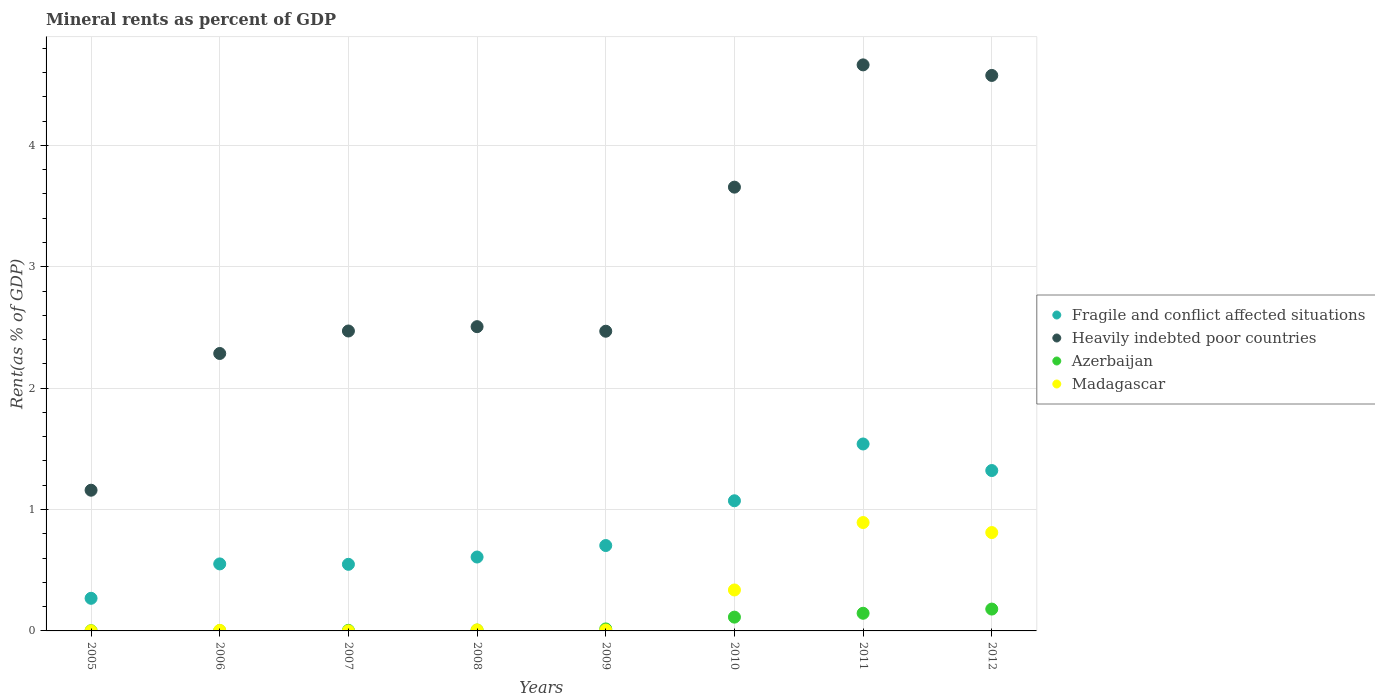Is the number of dotlines equal to the number of legend labels?
Provide a succinct answer. Yes. What is the mineral rent in Heavily indebted poor countries in 2011?
Ensure brevity in your answer.  4.66. Across all years, what is the maximum mineral rent in Azerbaijan?
Give a very brief answer. 0.18. Across all years, what is the minimum mineral rent in Madagascar?
Ensure brevity in your answer.  0. In which year was the mineral rent in Heavily indebted poor countries maximum?
Your response must be concise. 2011. In which year was the mineral rent in Heavily indebted poor countries minimum?
Give a very brief answer. 2005. What is the total mineral rent in Fragile and conflict affected situations in the graph?
Provide a short and direct response. 6.62. What is the difference between the mineral rent in Heavily indebted poor countries in 2009 and that in 2011?
Provide a short and direct response. -2.19. What is the difference between the mineral rent in Azerbaijan in 2006 and the mineral rent in Heavily indebted poor countries in 2010?
Your answer should be compact. -3.65. What is the average mineral rent in Madagascar per year?
Make the answer very short. 0.26. In the year 2010, what is the difference between the mineral rent in Madagascar and mineral rent in Fragile and conflict affected situations?
Provide a short and direct response. -0.73. In how many years, is the mineral rent in Heavily indebted poor countries greater than 0.8 %?
Make the answer very short. 8. What is the ratio of the mineral rent in Azerbaijan in 2006 to that in 2009?
Your answer should be very brief. 0.13. Is the mineral rent in Heavily indebted poor countries in 2008 less than that in 2011?
Keep it short and to the point. Yes. Is the difference between the mineral rent in Madagascar in 2006 and 2012 greater than the difference between the mineral rent in Fragile and conflict affected situations in 2006 and 2012?
Offer a very short reply. No. What is the difference between the highest and the second highest mineral rent in Heavily indebted poor countries?
Give a very brief answer. 0.09. What is the difference between the highest and the lowest mineral rent in Azerbaijan?
Give a very brief answer. 0.18. In how many years, is the mineral rent in Fragile and conflict affected situations greater than the average mineral rent in Fragile and conflict affected situations taken over all years?
Your answer should be very brief. 3. Is it the case that in every year, the sum of the mineral rent in Madagascar and mineral rent in Heavily indebted poor countries  is greater than the sum of mineral rent in Fragile and conflict affected situations and mineral rent in Azerbaijan?
Offer a terse response. No. Does the mineral rent in Heavily indebted poor countries monotonically increase over the years?
Keep it short and to the point. No. How many dotlines are there?
Ensure brevity in your answer.  4. Are the values on the major ticks of Y-axis written in scientific E-notation?
Keep it short and to the point. No. Does the graph contain any zero values?
Offer a very short reply. No. Does the graph contain grids?
Your response must be concise. Yes. What is the title of the graph?
Offer a very short reply. Mineral rents as percent of GDP. What is the label or title of the Y-axis?
Your answer should be compact. Rent(as % of GDP). What is the Rent(as % of GDP) in Fragile and conflict affected situations in 2005?
Keep it short and to the point. 0.27. What is the Rent(as % of GDP) in Heavily indebted poor countries in 2005?
Your response must be concise. 1.16. What is the Rent(as % of GDP) of Azerbaijan in 2005?
Ensure brevity in your answer.  0. What is the Rent(as % of GDP) in Madagascar in 2005?
Ensure brevity in your answer.  0. What is the Rent(as % of GDP) of Fragile and conflict affected situations in 2006?
Offer a terse response. 0.55. What is the Rent(as % of GDP) in Heavily indebted poor countries in 2006?
Ensure brevity in your answer.  2.29. What is the Rent(as % of GDP) of Azerbaijan in 2006?
Ensure brevity in your answer.  0. What is the Rent(as % of GDP) in Madagascar in 2006?
Ensure brevity in your answer.  0. What is the Rent(as % of GDP) of Fragile and conflict affected situations in 2007?
Provide a succinct answer. 0.55. What is the Rent(as % of GDP) of Heavily indebted poor countries in 2007?
Keep it short and to the point. 2.47. What is the Rent(as % of GDP) in Azerbaijan in 2007?
Provide a succinct answer. 0. What is the Rent(as % of GDP) in Madagascar in 2007?
Provide a short and direct response. 0. What is the Rent(as % of GDP) in Fragile and conflict affected situations in 2008?
Make the answer very short. 0.61. What is the Rent(as % of GDP) in Heavily indebted poor countries in 2008?
Provide a succinct answer. 2.51. What is the Rent(as % of GDP) of Azerbaijan in 2008?
Provide a succinct answer. 0.01. What is the Rent(as % of GDP) of Madagascar in 2008?
Provide a short and direct response. 0.01. What is the Rent(as % of GDP) of Fragile and conflict affected situations in 2009?
Provide a short and direct response. 0.7. What is the Rent(as % of GDP) in Heavily indebted poor countries in 2009?
Your answer should be compact. 2.47. What is the Rent(as % of GDP) of Azerbaijan in 2009?
Give a very brief answer. 0.02. What is the Rent(as % of GDP) in Madagascar in 2009?
Your answer should be very brief. 0.01. What is the Rent(as % of GDP) in Fragile and conflict affected situations in 2010?
Keep it short and to the point. 1.07. What is the Rent(as % of GDP) in Heavily indebted poor countries in 2010?
Your response must be concise. 3.66. What is the Rent(as % of GDP) in Azerbaijan in 2010?
Your response must be concise. 0.11. What is the Rent(as % of GDP) of Madagascar in 2010?
Make the answer very short. 0.34. What is the Rent(as % of GDP) of Fragile and conflict affected situations in 2011?
Offer a very short reply. 1.54. What is the Rent(as % of GDP) of Heavily indebted poor countries in 2011?
Give a very brief answer. 4.66. What is the Rent(as % of GDP) of Azerbaijan in 2011?
Your response must be concise. 0.15. What is the Rent(as % of GDP) in Madagascar in 2011?
Give a very brief answer. 0.89. What is the Rent(as % of GDP) in Fragile and conflict affected situations in 2012?
Your answer should be very brief. 1.32. What is the Rent(as % of GDP) in Heavily indebted poor countries in 2012?
Make the answer very short. 4.58. What is the Rent(as % of GDP) in Azerbaijan in 2012?
Offer a terse response. 0.18. What is the Rent(as % of GDP) of Madagascar in 2012?
Give a very brief answer. 0.81. Across all years, what is the maximum Rent(as % of GDP) of Fragile and conflict affected situations?
Offer a terse response. 1.54. Across all years, what is the maximum Rent(as % of GDP) of Heavily indebted poor countries?
Keep it short and to the point. 4.66. Across all years, what is the maximum Rent(as % of GDP) in Azerbaijan?
Make the answer very short. 0.18. Across all years, what is the maximum Rent(as % of GDP) of Madagascar?
Offer a terse response. 0.89. Across all years, what is the minimum Rent(as % of GDP) in Fragile and conflict affected situations?
Provide a short and direct response. 0.27. Across all years, what is the minimum Rent(as % of GDP) in Heavily indebted poor countries?
Offer a terse response. 1.16. Across all years, what is the minimum Rent(as % of GDP) in Azerbaijan?
Make the answer very short. 0. Across all years, what is the minimum Rent(as % of GDP) of Madagascar?
Give a very brief answer. 0. What is the total Rent(as % of GDP) in Fragile and conflict affected situations in the graph?
Keep it short and to the point. 6.62. What is the total Rent(as % of GDP) in Heavily indebted poor countries in the graph?
Your answer should be very brief. 23.79. What is the total Rent(as % of GDP) of Azerbaijan in the graph?
Ensure brevity in your answer.  0.47. What is the total Rent(as % of GDP) of Madagascar in the graph?
Your response must be concise. 2.06. What is the difference between the Rent(as % of GDP) of Fragile and conflict affected situations in 2005 and that in 2006?
Provide a succinct answer. -0.28. What is the difference between the Rent(as % of GDP) in Heavily indebted poor countries in 2005 and that in 2006?
Your response must be concise. -1.13. What is the difference between the Rent(as % of GDP) in Azerbaijan in 2005 and that in 2006?
Provide a short and direct response. -0. What is the difference between the Rent(as % of GDP) of Madagascar in 2005 and that in 2006?
Provide a short and direct response. -0. What is the difference between the Rent(as % of GDP) of Fragile and conflict affected situations in 2005 and that in 2007?
Provide a succinct answer. -0.28. What is the difference between the Rent(as % of GDP) in Heavily indebted poor countries in 2005 and that in 2007?
Offer a terse response. -1.31. What is the difference between the Rent(as % of GDP) in Azerbaijan in 2005 and that in 2007?
Your answer should be compact. -0. What is the difference between the Rent(as % of GDP) in Madagascar in 2005 and that in 2007?
Ensure brevity in your answer.  0. What is the difference between the Rent(as % of GDP) of Fragile and conflict affected situations in 2005 and that in 2008?
Offer a terse response. -0.34. What is the difference between the Rent(as % of GDP) of Heavily indebted poor countries in 2005 and that in 2008?
Provide a succinct answer. -1.35. What is the difference between the Rent(as % of GDP) in Azerbaijan in 2005 and that in 2008?
Your answer should be very brief. -0.01. What is the difference between the Rent(as % of GDP) of Madagascar in 2005 and that in 2008?
Give a very brief answer. -0.01. What is the difference between the Rent(as % of GDP) in Fragile and conflict affected situations in 2005 and that in 2009?
Provide a short and direct response. -0.43. What is the difference between the Rent(as % of GDP) of Heavily indebted poor countries in 2005 and that in 2009?
Keep it short and to the point. -1.31. What is the difference between the Rent(as % of GDP) in Azerbaijan in 2005 and that in 2009?
Provide a short and direct response. -0.01. What is the difference between the Rent(as % of GDP) of Madagascar in 2005 and that in 2009?
Offer a very short reply. -0.01. What is the difference between the Rent(as % of GDP) of Fragile and conflict affected situations in 2005 and that in 2010?
Give a very brief answer. -0.8. What is the difference between the Rent(as % of GDP) of Heavily indebted poor countries in 2005 and that in 2010?
Your answer should be very brief. -2.5. What is the difference between the Rent(as % of GDP) of Azerbaijan in 2005 and that in 2010?
Make the answer very short. -0.11. What is the difference between the Rent(as % of GDP) in Madagascar in 2005 and that in 2010?
Offer a terse response. -0.34. What is the difference between the Rent(as % of GDP) in Fragile and conflict affected situations in 2005 and that in 2011?
Make the answer very short. -1.27. What is the difference between the Rent(as % of GDP) of Heavily indebted poor countries in 2005 and that in 2011?
Offer a very short reply. -3.5. What is the difference between the Rent(as % of GDP) in Azerbaijan in 2005 and that in 2011?
Make the answer very short. -0.14. What is the difference between the Rent(as % of GDP) of Madagascar in 2005 and that in 2011?
Offer a very short reply. -0.89. What is the difference between the Rent(as % of GDP) of Fragile and conflict affected situations in 2005 and that in 2012?
Provide a short and direct response. -1.05. What is the difference between the Rent(as % of GDP) of Heavily indebted poor countries in 2005 and that in 2012?
Provide a short and direct response. -3.42. What is the difference between the Rent(as % of GDP) of Azerbaijan in 2005 and that in 2012?
Keep it short and to the point. -0.18. What is the difference between the Rent(as % of GDP) of Madagascar in 2005 and that in 2012?
Your answer should be compact. -0.81. What is the difference between the Rent(as % of GDP) in Fragile and conflict affected situations in 2006 and that in 2007?
Offer a terse response. 0. What is the difference between the Rent(as % of GDP) in Heavily indebted poor countries in 2006 and that in 2007?
Offer a very short reply. -0.19. What is the difference between the Rent(as % of GDP) of Azerbaijan in 2006 and that in 2007?
Make the answer very short. -0. What is the difference between the Rent(as % of GDP) in Madagascar in 2006 and that in 2007?
Ensure brevity in your answer.  0. What is the difference between the Rent(as % of GDP) in Fragile and conflict affected situations in 2006 and that in 2008?
Ensure brevity in your answer.  -0.06. What is the difference between the Rent(as % of GDP) in Heavily indebted poor countries in 2006 and that in 2008?
Give a very brief answer. -0.22. What is the difference between the Rent(as % of GDP) in Azerbaijan in 2006 and that in 2008?
Offer a terse response. -0. What is the difference between the Rent(as % of GDP) of Madagascar in 2006 and that in 2008?
Ensure brevity in your answer.  -0. What is the difference between the Rent(as % of GDP) in Fragile and conflict affected situations in 2006 and that in 2009?
Make the answer very short. -0.15. What is the difference between the Rent(as % of GDP) in Heavily indebted poor countries in 2006 and that in 2009?
Your answer should be very brief. -0.18. What is the difference between the Rent(as % of GDP) in Azerbaijan in 2006 and that in 2009?
Keep it short and to the point. -0.01. What is the difference between the Rent(as % of GDP) in Madagascar in 2006 and that in 2009?
Make the answer very short. -0. What is the difference between the Rent(as % of GDP) of Fragile and conflict affected situations in 2006 and that in 2010?
Your answer should be compact. -0.52. What is the difference between the Rent(as % of GDP) in Heavily indebted poor countries in 2006 and that in 2010?
Your answer should be very brief. -1.37. What is the difference between the Rent(as % of GDP) in Azerbaijan in 2006 and that in 2010?
Your answer should be very brief. -0.11. What is the difference between the Rent(as % of GDP) in Madagascar in 2006 and that in 2010?
Make the answer very short. -0.33. What is the difference between the Rent(as % of GDP) of Fragile and conflict affected situations in 2006 and that in 2011?
Your answer should be compact. -0.99. What is the difference between the Rent(as % of GDP) of Heavily indebted poor countries in 2006 and that in 2011?
Offer a terse response. -2.38. What is the difference between the Rent(as % of GDP) in Azerbaijan in 2006 and that in 2011?
Provide a short and direct response. -0.14. What is the difference between the Rent(as % of GDP) in Madagascar in 2006 and that in 2011?
Offer a very short reply. -0.89. What is the difference between the Rent(as % of GDP) of Fragile and conflict affected situations in 2006 and that in 2012?
Offer a very short reply. -0.77. What is the difference between the Rent(as % of GDP) in Heavily indebted poor countries in 2006 and that in 2012?
Your answer should be very brief. -2.29. What is the difference between the Rent(as % of GDP) of Azerbaijan in 2006 and that in 2012?
Give a very brief answer. -0.18. What is the difference between the Rent(as % of GDP) of Madagascar in 2006 and that in 2012?
Give a very brief answer. -0.81. What is the difference between the Rent(as % of GDP) of Fragile and conflict affected situations in 2007 and that in 2008?
Give a very brief answer. -0.06. What is the difference between the Rent(as % of GDP) of Heavily indebted poor countries in 2007 and that in 2008?
Offer a very short reply. -0.04. What is the difference between the Rent(as % of GDP) of Azerbaijan in 2007 and that in 2008?
Make the answer very short. -0. What is the difference between the Rent(as % of GDP) in Madagascar in 2007 and that in 2008?
Keep it short and to the point. -0.01. What is the difference between the Rent(as % of GDP) in Fragile and conflict affected situations in 2007 and that in 2009?
Ensure brevity in your answer.  -0.15. What is the difference between the Rent(as % of GDP) of Heavily indebted poor countries in 2007 and that in 2009?
Offer a terse response. 0. What is the difference between the Rent(as % of GDP) of Azerbaijan in 2007 and that in 2009?
Your answer should be very brief. -0.01. What is the difference between the Rent(as % of GDP) of Madagascar in 2007 and that in 2009?
Keep it short and to the point. -0.01. What is the difference between the Rent(as % of GDP) of Fragile and conflict affected situations in 2007 and that in 2010?
Keep it short and to the point. -0.52. What is the difference between the Rent(as % of GDP) in Heavily indebted poor countries in 2007 and that in 2010?
Provide a short and direct response. -1.19. What is the difference between the Rent(as % of GDP) of Azerbaijan in 2007 and that in 2010?
Your answer should be very brief. -0.11. What is the difference between the Rent(as % of GDP) of Madagascar in 2007 and that in 2010?
Keep it short and to the point. -0.34. What is the difference between the Rent(as % of GDP) of Fragile and conflict affected situations in 2007 and that in 2011?
Give a very brief answer. -0.99. What is the difference between the Rent(as % of GDP) in Heavily indebted poor countries in 2007 and that in 2011?
Give a very brief answer. -2.19. What is the difference between the Rent(as % of GDP) of Azerbaijan in 2007 and that in 2011?
Ensure brevity in your answer.  -0.14. What is the difference between the Rent(as % of GDP) of Madagascar in 2007 and that in 2011?
Keep it short and to the point. -0.89. What is the difference between the Rent(as % of GDP) in Fragile and conflict affected situations in 2007 and that in 2012?
Make the answer very short. -0.77. What is the difference between the Rent(as % of GDP) of Heavily indebted poor countries in 2007 and that in 2012?
Your response must be concise. -2.11. What is the difference between the Rent(as % of GDP) of Azerbaijan in 2007 and that in 2012?
Ensure brevity in your answer.  -0.18. What is the difference between the Rent(as % of GDP) in Madagascar in 2007 and that in 2012?
Keep it short and to the point. -0.81. What is the difference between the Rent(as % of GDP) in Fragile and conflict affected situations in 2008 and that in 2009?
Provide a short and direct response. -0.09. What is the difference between the Rent(as % of GDP) of Heavily indebted poor countries in 2008 and that in 2009?
Provide a succinct answer. 0.04. What is the difference between the Rent(as % of GDP) in Azerbaijan in 2008 and that in 2009?
Your answer should be compact. -0.01. What is the difference between the Rent(as % of GDP) in Madagascar in 2008 and that in 2009?
Make the answer very short. 0. What is the difference between the Rent(as % of GDP) of Fragile and conflict affected situations in 2008 and that in 2010?
Your answer should be very brief. -0.46. What is the difference between the Rent(as % of GDP) in Heavily indebted poor countries in 2008 and that in 2010?
Provide a succinct answer. -1.15. What is the difference between the Rent(as % of GDP) of Azerbaijan in 2008 and that in 2010?
Ensure brevity in your answer.  -0.11. What is the difference between the Rent(as % of GDP) of Madagascar in 2008 and that in 2010?
Offer a very short reply. -0.33. What is the difference between the Rent(as % of GDP) in Fragile and conflict affected situations in 2008 and that in 2011?
Provide a short and direct response. -0.93. What is the difference between the Rent(as % of GDP) of Heavily indebted poor countries in 2008 and that in 2011?
Give a very brief answer. -2.16. What is the difference between the Rent(as % of GDP) of Azerbaijan in 2008 and that in 2011?
Ensure brevity in your answer.  -0.14. What is the difference between the Rent(as % of GDP) in Madagascar in 2008 and that in 2011?
Offer a terse response. -0.88. What is the difference between the Rent(as % of GDP) of Fragile and conflict affected situations in 2008 and that in 2012?
Keep it short and to the point. -0.71. What is the difference between the Rent(as % of GDP) in Heavily indebted poor countries in 2008 and that in 2012?
Provide a succinct answer. -2.07. What is the difference between the Rent(as % of GDP) in Azerbaijan in 2008 and that in 2012?
Provide a short and direct response. -0.17. What is the difference between the Rent(as % of GDP) in Madagascar in 2008 and that in 2012?
Give a very brief answer. -0.8. What is the difference between the Rent(as % of GDP) of Fragile and conflict affected situations in 2009 and that in 2010?
Make the answer very short. -0.37. What is the difference between the Rent(as % of GDP) of Heavily indebted poor countries in 2009 and that in 2010?
Give a very brief answer. -1.19. What is the difference between the Rent(as % of GDP) of Azerbaijan in 2009 and that in 2010?
Offer a very short reply. -0.1. What is the difference between the Rent(as % of GDP) of Madagascar in 2009 and that in 2010?
Make the answer very short. -0.33. What is the difference between the Rent(as % of GDP) in Fragile and conflict affected situations in 2009 and that in 2011?
Ensure brevity in your answer.  -0.84. What is the difference between the Rent(as % of GDP) in Heavily indebted poor countries in 2009 and that in 2011?
Offer a very short reply. -2.19. What is the difference between the Rent(as % of GDP) in Azerbaijan in 2009 and that in 2011?
Your answer should be compact. -0.13. What is the difference between the Rent(as % of GDP) in Madagascar in 2009 and that in 2011?
Your answer should be very brief. -0.89. What is the difference between the Rent(as % of GDP) in Fragile and conflict affected situations in 2009 and that in 2012?
Your answer should be very brief. -0.62. What is the difference between the Rent(as % of GDP) in Heavily indebted poor countries in 2009 and that in 2012?
Provide a short and direct response. -2.11. What is the difference between the Rent(as % of GDP) in Azerbaijan in 2009 and that in 2012?
Your answer should be very brief. -0.16. What is the difference between the Rent(as % of GDP) of Madagascar in 2009 and that in 2012?
Give a very brief answer. -0.8. What is the difference between the Rent(as % of GDP) of Fragile and conflict affected situations in 2010 and that in 2011?
Make the answer very short. -0.47. What is the difference between the Rent(as % of GDP) of Heavily indebted poor countries in 2010 and that in 2011?
Ensure brevity in your answer.  -1.01. What is the difference between the Rent(as % of GDP) of Azerbaijan in 2010 and that in 2011?
Offer a very short reply. -0.03. What is the difference between the Rent(as % of GDP) of Madagascar in 2010 and that in 2011?
Your answer should be compact. -0.56. What is the difference between the Rent(as % of GDP) in Fragile and conflict affected situations in 2010 and that in 2012?
Keep it short and to the point. -0.25. What is the difference between the Rent(as % of GDP) of Heavily indebted poor countries in 2010 and that in 2012?
Your response must be concise. -0.92. What is the difference between the Rent(as % of GDP) of Azerbaijan in 2010 and that in 2012?
Give a very brief answer. -0.07. What is the difference between the Rent(as % of GDP) in Madagascar in 2010 and that in 2012?
Give a very brief answer. -0.47. What is the difference between the Rent(as % of GDP) of Fragile and conflict affected situations in 2011 and that in 2012?
Your answer should be very brief. 0.22. What is the difference between the Rent(as % of GDP) of Heavily indebted poor countries in 2011 and that in 2012?
Make the answer very short. 0.09. What is the difference between the Rent(as % of GDP) of Azerbaijan in 2011 and that in 2012?
Keep it short and to the point. -0.03. What is the difference between the Rent(as % of GDP) in Madagascar in 2011 and that in 2012?
Offer a terse response. 0.08. What is the difference between the Rent(as % of GDP) in Fragile and conflict affected situations in 2005 and the Rent(as % of GDP) in Heavily indebted poor countries in 2006?
Make the answer very short. -2.02. What is the difference between the Rent(as % of GDP) in Fragile and conflict affected situations in 2005 and the Rent(as % of GDP) in Azerbaijan in 2006?
Keep it short and to the point. 0.27. What is the difference between the Rent(as % of GDP) in Fragile and conflict affected situations in 2005 and the Rent(as % of GDP) in Madagascar in 2006?
Ensure brevity in your answer.  0.26. What is the difference between the Rent(as % of GDP) in Heavily indebted poor countries in 2005 and the Rent(as % of GDP) in Azerbaijan in 2006?
Offer a terse response. 1.16. What is the difference between the Rent(as % of GDP) of Heavily indebted poor countries in 2005 and the Rent(as % of GDP) of Madagascar in 2006?
Give a very brief answer. 1.15. What is the difference between the Rent(as % of GDP) of Azerbaijan in 2005 and the Rent(as % of GDP) of Madagascar in 2006?
Offer a terse response. -0. What is the difference between the Rent(as % of GDP) of Fragile and conflict affected situations in 2005 and the Rent(as % of GDP) of Heavily indebted poor countries in 2007?
Your answer should be compact. -2.2. What is the difference between the Rent(as % of GDP) in Fragile and conflict affected situations in 2005 and the Rent(as % of GDP) in Azerbaijan in 2007?
Offer a very short reply. 0.26. What is the difference between the Rent(as % of GDP) of Fragile and conflict affected situations in 2005 and the Rent(as % of GDP) of Madagascar in 2007?
Your response must be concise. 0.27. What is the difference between the Rent(as % of GDP) of Heavily indebted poor countries in 2005 and the Rent(as % of GDP) of Azerbaijan in 2007?
Provide a short and direct response. 1.15. What is the difference between the Rent(as % of GDP) of Heavily indebted poor countries in 2005 and the Rent(as % of GDP) of Madagascar in 2007?
Offer a terse response. 1.16. What is the difference between the Rent(as % of GDP) in Azerbaijan in 2005 and the Rent(as % of GDP) in Madagascar in 2007?
Offer a terse response. 0. What is the difference between the Rent(as % of GDP) of Fragile and conflict affected situations in 2005 and the Rent(as % of GDP) of Heavily indebted poor countries in 2008?
Offer a terse response. -2.24. What is the difference between the Rent(as % of GDP) in Fragile and conflict affected situations in 2005 and the Rent(as % of GDP) in Azerbaijan in 2008?
Your answer should be very brief. 0.26. What is the difference between the Rent(as % of GDP) in Fragile and conflict affected situations in 2005 and the Rent(as % of GDP) in Madagascar in 2008?
Make the answer very short. 0.26. What is the difference between the Rent(as % of GDP) of Heavily indebted poor countries in 2005 and the Rent(as % of GDP) of Azerbaijan in 2008?
Your answer should be compact. 1.15. What is the difference between the Rent(as % of GDP) in Heavily indebted poor countries in 2005 and the Rent(as % of GDP) in Madagascar in 2008?
Your response must be concise. 1.15. What is the difference between the Rent(as % of GDP) in Azerbaijan in 2005 and the Rent(as % of GDP) in Madagascar in 2008?
Offer a very short reply. -0.01. What is the difference between the Rent(as % of GDP) in Fragile and conflict affected situations in 2005 and the Rent(as % of GDP) in Heavily indebted poor countries in 2009?
Ensure brevity in your answer.  -2.2. What is the difference between the Rent(as % of GDP) of Fragile and conflict affected situations in 2005 and the Rent(as % of GDP) of Azerbaijan in 2009?
Offer a very short reply. 0.25. What is the difference between the Rent(as % of GDP) in Fragile and conflict affected situations in 2005 and the Rent(as % of GDP) in Madagascar in 2009?
Your answer should be very brief. 0.26. What is the difference between the Rent(as % of GDP) in Heavily indebted poor countries in 2005 and the Rent(as % of GDP) in Azerbaijan in 2009?
Ensure brevity in your answer.  1.14. What is the difference between the Rent(as % of GDP) of Heavily indebted poor countries in 2005 and the Rent(as % of GDP) of Madagascar in 2009?
Keep it short and to the point. 1.15. What is the difference between the Rent(as % of GDP) of Azerbaijan in 2005 and the Rent(as % of GDP) of Madagascar in 2009?
Your answer should be very brief. -0.01. What is the difference between the Rent(as % of GDP) in Fragile and conflict affected situations in 2005 and the Rent(as % of GDP) in Heavily indebted poor countries in 2010?
Keep it short and to the point. -3.39. What is the difference between the Rent(as % of GDP) in Fragile and conflict affected situations in 2005 and the Rent(as % of GDP) in Azerbaijan in 2010?
Offer a very short reply. 0.16. What is the difference between the Rent(as % of GDP) of Fragile and conflict affected situations in 2005 and the Rent(as % of GDP) of Madagascar in 2010?
Offer a terse response. -0.07. What is the difference between the Rent(as % of GDP) in Heavily indebted poor countries in 2005 and the Rent(as % of GDP) in Azerbaijan in 2010?
Offer a very short reply. 1.05. What is the difference between the Rent(as % of GDP) of Heavily indebted poor countries in 2005 and the Rent(as % of GDP) of Madagascar in 2010?
Ensure brevity in your answer.  0.82. What is the difference between the Rent(as % of GDP) in Azerbaijan in 2005 and the Rent(as % of GDP) in Madagascar in 2010?
Offer a very short reply. -0.34. What is the difference between the Rent(as % of GDP) of Fragile and conflict affected situations in 2005 and the Rent(as % of GDP) of Heavily indebted poor countries in 2011?
Your answer should be compact. -4.39. What is the difference between the Rent(as % of GDP) of Fragile and conflict affected situations in 2005 and the Rent(as % of GDP) of Azerbaijan in 2011?
Your answer should be very brief. 0.12. What is the difference between the Rent(as % of GDP) of Fragile and conflict affected situations in 2005 and the Rent(as % of GDP) of Madagascar in 2011?
Make the answer very short. -0.62. What is the difference between the Rent(as % of GDP) of Heavily indebted poor countries in 2005 and the Rent(as % of GDP) of Azerbaijan in 2011?
Your answer should be very brief. 1.01. What is the difference between the Rent(as % of GDP) in Heavily indebted poor countries in 2005 and the Rent(as % of GDP) in Madagascar in 2011?
Offer a very short reply. 0.27. What is the difference between the Rent(as % of GDP) in Azerbaijan in 2005 and the Rent(as % of GDP) in Madagascar in 2011?
Your answer should be very brief. -0.89. What is the difference between the Rent(as % of GDP) of Fragile and conflict affected situations in 2005 and the Rent(as % of GDP) of Heavily indebted poor countries in 2012?
Give a very brief answer. -4.31. What is the difference between the Rent(as % of GDP) of Fragile and conflict affected situations in 2005 and the Rent(as % of GDP) of Azerbaijan in 2012?
Provide a succinct answer. 0.09. What is the difference between the Rent(as % of GDP) of Fragile and conflict affected situations in 2005 and the Rent(as % of GDP) of Madagascar in 2012?
Offer a terse response. -0.54. What is the difference between the Rent(as % of GDP) in Heavily indebted poor countries in 2005 and the Rent(as % of GDP) in Azerbaijan in 2012?
Offer a terse response. 0.98. What is the difference between the Rent(as % of GDP) of Heavily indebted poor countries in 2005 and the Rent(as % of GDP) of Madagascar in 2012?
Give a very brief answer. 0.35. What is the difference between the Rent(as % of GDP) in Azerbaijan in 2005 and the Rent(as % of GDP) in Madagascar in 2012?
Your answer should be compact. -0.81. What is the difference between the Rent(as % of GDP) of Fragile and conflict affected situations in 2006 and the Rent(as % of GDP) of Heavily indebted poor countries in 2007?
Give a very brief answer. -1.92. What is the difference between the Rent(as % of GDP) in Fragile and conflict affected situations in 2006 and the Rent(as % of GDP) in Azerbaijan in 2007?
Your answer should be compact. 0.55. What is the difference between the Rent(as % of GDP) of Fragile and conflict affected situations in 2006 and the Rent(as % of GDP) of Madagascar in 2007?
Provide a succinct answer. 0.55. What is the difference between the Rent(as % of GDP) in Heavily indebted poor countries in 2006 and the Rent(as % of GDP) in Azerbaijan in 2007?
Offer a very short reply. 2.28. What is the difference between the Rent(as % of GDP) of Heavily indebted poor countries in 2006 and the Rent(as % of GDP) of Madagascar in 2007?
Your answer should be compact. 2.29. What is the difference between the Rent(as % of GDP) of Azerbaijan in 2006 and the Rent(as % of GDP) of Madagascar in 2007?
Keep it short and to the point. 0. What is the difference between the Rent(as % of GDP) in Fragile and conflict affected situations in 2006 and the Rent(as % of GDP) in Heavily indebted poor countries in 2008?
Your response must be concise. -1.95. What is the difference between the Rent(as % of GDP) in Fragile and conflict affected situations in 2006 and the Rent(as % of GDP) in Azerbaijan in 2008?
Give a very brief answer. 0.55. What is the difference between the Rent(as % of GDP) in Fragile and conflict affected situations in 2006 and the Rent(as % of GDP) in Madagascar in 2008?
Keep it short and to the point. 0.54. What is the difference between the Rent(as % of GDP) in Heavily indebted poor countries in 2006 and the Rent(as % of GDP) in Azerbaijan in 2008?
Your answer should be compact. 2.28. What is the difference between the Rent(as % of GDP) in Heavily indebted poor countries in 2006 and the Rent(as % of GDP) in Madagascar in 2008?
Your response must be concise. 2.28. What is the difference between the Rent(as % of GDP) of Azerbaijan in 2006 and the Rent(as % of GDP) of Madagascar in 2008?
Ensure brevity in your answer.  -0.01. What is the difference between the Rent(as % of GDP) of Fragile and conflict affected situations in 2006 and the Rent(as % of GDP) of Heavily indebted poor countries in 2009?
Ensure brevity in your answer.  -1.92. What is the difference between the Rent(as % of GDP) in Fragile and conflict affected situations in 2006 and the Rent(as % of GDP) in Azerbaijan in 2009?
Your response must be concise. 0.54. What is the difference between the Rent(as % of GDP) in Fragile and conflict affected situations in 2006 and the Rent(as % of GDP) in Madagascar in 2009?
Keep it short and to the point. 0.55. What is the difference between the Rent(as % of GDP) in Heavily indebted poor countries in 2006 and the Rent(as % of GDP) in Azerbaijan in 2009?
Your response must be concise. 2.27. What is the difference between the Rent(as % of GDP) of Heavily indebted poor countries in 2006 and the Rent(as % of GDP) of Madagascar in 2009?
Make the answer very short. 2.28. What is the difference between the Rent(as % of GDP) in Azerbaijan in 2006 and the Rent(as % of GDP) in Madagascar in 2009?
Ensure brevity in your answer.  -0.01. What is the difference between the Rent(as % of GDP) in Fragile and conflict affected situations in 2006 and the Rent(as % of GDP) in Heavily indebted poor countries in 2010?
Your response must be concise. -3.1. What is the difference between the Rent(as % of GDP) in Fragile and conflict affected situations in 2006 and the Rent(as % of GDP) in Azerbaijan in 2010?
Give a very brief answer. 0.44. What is the difference between the Rent(as % of GDP) of Fragile and conflict affected situations in 2006 and the Rent(as % of GDP) of Madagascar in 2010?
Provide a succinct answer. 0.21. What is the difference between the Rent(as % of GDP) of Heavily indebted poor countries in 2006 and the Rent(as % of GDP) of Azerbaijan in 2010?
Provide a short and direct response. 2.17. What is the difference between the Rent(as % of GDP) in Heavily indebted poor countries in 2006 and the Rent(as % of GDP) in Madagascar in 2010?
Your response must be concise. 1.95. What is the difference between the Rent(as % of GDP) in Azerbaijan in 2006 and the Rent(as % of GDP) in Madagascar in 2010?
Ensure brevity in your answer.  -0.34. What is the difference between the Rent(as % of GDP) in Fragile and conflict affected situations in 2006 and the Rent(as % of GDP) in Heavily indebted poor countries in 2011?
Offer a very short reply. -4.11. What is the difference between the Rent(as % of GDP) in Fragile and conflict affected situations in 2006 and the Rent(as % of GDP) in Azerbaijan in 2011?
Provide a succinct answer. 0.41. What is the difference between the Rent(as % of GDP) in Fragile and conflict affected situations in 2006 and the Rent(as % of GDP) in Madagascar in 2011?
Your answer should be compact. -0.34. What is the difference between the Rent(as % of GDP) in Heavily indebted poor countries in 2006 and the Rent(as % of GDP) in Azerbaijan in 2011?
Your answer should be very brief. 2.14. What is the difference between the Rent(as % of GDP) in Heavily indebted poor countries in 2006 and the Rent(as % of GDP) in Madagascar in 2011?
Make the answer very short. 1.39. What is the difference between the Rent(as % of GDP) of Azerbaijan in 2006 and the Rent(as % of GDP) of Madagascar in 2011?
Your answer should be compact. -0.89. What is the difference between the Rent(as % of GDP) in Fragile and conflict affected situations in 2006 and the Rent(as % of GDP) in Heavily indebted poor countries in 2012?
Provide a succinct answer. -4.02. What is the difference between the Rent(as % of GDP) of Fragile and conflict affected situations in 2006 and the Rent(as % of GDP) of Azerbaijan in 2012?
Keep it short and to the point. 0.37. What is the difference between the Rent(as % of GDP) of Fragile and conflict affected situations in 2006 and the Rent(as % of GDP) of Madagascar in 2012?
Offer a very short reply. -0.26. What is the difference between the Rent(as % of GDP) in Heavily indebted poor countries in 2006 and the Rent(as % of GDP) in Azerbaijan in 2012?
Your answer should be very brief. 2.11. What is the difference between the Rent(as % of GDP) of Heavily indebted poor countries in 2006 and the Rent(as % of GDP) of Madagascar in 2012?
Your response must be concise. 1.48. What is the difference between the Rent(as % of GDP) in Azerbaijan in 2006 and the Rent(as % of GDP) in Madagascar in 2012?
Ensure brevity in your answer.  -0.81. What is the difference between the Rent(as % of GDP) in Fragile and conflict affected situations in 2007 and the Rent(as % of GDP) in Heavily indebted poor countries in 2008?
Give a very brief answer. -1.96. What is the difference between the Rent(as % of GDP) of Fragile and conflict affected situations in 2007 and the Rent(as % of GDP) of Azerbaijan in 2008?
Keep it short and to the point. 0.54. What is the difference between the Rent(as % of GDP) of Fragile and conflict affected situations in 2007 and the Rent(as % of GDP) of Madagascar in 2008?
Your answer should be very brief. 0.54. What is the difference between the Rent(as % of GDP) of Heavily indebted poor countries in 2007 and the Rent(as % of GDP) of Azerbaijan in 2008?
Your response must be concise. 2.46. What is the difference between the Rent(as % of GDP) in Heavily indebted poor countries in 2007 and the Rent(as % of GDP) in Madagascar in 2008?
Your response must be concise. 2.46. What is the difference between the Rent(as % of GDP) of Azerbaijan in 2007 and the Rent(as % of GDP) of Madagascar in 2008?
Your answer should be very brief. -0. What is the difference between the Rent(as % of GDP) of Fragile and conflict affected situations in 2007 and the Rent(as % of GDP) of Heavily indebted poor countries in 2009?
Ensure brevity in your answer.  -1.92. What is the difference between the Rent(as % of GDP) of Fragile and conflict affected situations in 2007 and the Rent(as % of GDP) of Azerbaijan in 2009?
Ensure brevity in your answer.  0.53. What is the difference between the Rent(as % of GDP) in Fragile and conflict affected situations in 2007 and the Rent(as % of GDP) in Madagascar in 2009?
Make the answer very short. 0.54. What is the difference between the Rent(as % of GDP) of Heavily indebted poor countries in 2007 and the Rent(as % of GDP) of Azerbaijan in 2009?
Keep it short and to the point. 2.45. What is the difference between the Rent(as % of GDP) of Heavily indebted poor countries in 2007 and the Rent(as % of GDP) of Madagascar in 2009?
Make the answer very short. 2.46. What is the difference between the Rent(as % of GDP) in Azerbaijan in 2007 and the Rent(as % of GDP) in Madagascar in 2009?
Offer a terse response. -0. What is the difference between the Rent(as % of GDP) in Fragile and conflict affected situations in 2007 and the Rent(as % of GDP) in Heavily indebted poor countries in 2010?
Your answer should be compact. -3.11. What is the difference between the Rent(as % of GDP) in Fragile and conflict affected situations in 2007 and the Rent(as % of GDP) in Azerbaijan in 2010?
Provide a succinct answer. 0.44. What is the difference between the Rent(as % of GDP) of Fragile and conflict affected situations in 2007 and the Rent(as % of GDP) of Madagascar in 2010?
Your answer should be compact. 0.21. What is the difference between the Rent(as % of GDP) in Heavily indebted poor countries in 2007 and the Rent(as % of GDP) in Azerbaijan in 2010?
Keep it short and to the point. 2.36. What is the difference between the Rent(as % of GDP) of Heavily indebted poor countries in 2007 and the Rent(as % of GDP) of Madagascar in 2010?
Keep it short and to the point. 2.13. What is the difference between the Rent(as % of GDP) in Azerbaijan in 2007 and the Rent(as % of GDP) in Madagascar in 2010?
Your response must be concise. -0.33. What is the difference between the Rent(as % of GDP) of Fragile and conflict affected situations in 2007 and the Rent(as % of GDP) of Heavily indebted poor countries in 2011?
Make the answer very short. -4.11. What is the difference between the Rent(as % of GDP) in Fragile and conflict affected situations in 2007 and the Rent(as % of GDP) in Azerbaijan in 2011?
Ensure brevity in your answer.  0.4. What is the difference between the Rent(as % of GDP) in Fragile and conflict affected situations in 2007 and the Rent(as % of GDP) in Madagascar in 2011?
Provide a short and direct response. -0.34. What is the difference between the Rent(as % of GDP) of Heavily indebted poor countries in 2007 and the Rent(as % of GDP) of Azerbaijan in 2011?
Keep it short and to the point. 2.33. What is the difference between the Rent(as % of GDP) of Heavily indebted poor countries in 2007 and the Rent(as % of GDP) of Madagascar in 2011?
Keep it short and to the point. 1.58. What is the difference between the Rent(as % of GDP) in Azerbaijan in 2007 and the Rent(as % of GDP) in Madagascar in 2011?
Offer a terse response. -0.89. What is the difference between the Rent(as % of GDP) in Fragile and conflict affected situations in 2007 and the Rent(as % of GDP) in Heavily indebted poor countries in 2012?
Make the answer very short. -4.03. What is the difference between the Rent(as % of GDP) of Fragile and conflict affected situations in 2007 and the Rent(as % of GDP) of Azerbaijan in 2012?
Your answer should be compact. 0.37. What is the difference between the Rent(as % of GDP) of Fragile and conflict affected situations in 2007 and the Rent(as % of GDP) of Madagascar in 2012?
Ensure brevity in your answer.  -0.26. What is the difference between the Rent(as % of GDP) of Heavily indebted poor countries in 2007 and the Rent(as % of GDP) of Azerbaijan in 2012?
Offer a very short reply. 2.29. What is the difference between the Rent(as % of GDP) of Heavily indebted poor countries in 2007 and the Rent(as % of GDP) of Madagascar in 2012?
Offer a terse response. 1.66. What is the difference between the Rent(as % of GDP) of Azerbaijan in 2007 and the Rent(as % of GDP) of Madagascar in 2012?
Make the answer very short. -0.81. What is the difference between the Rent(as % of GDP) in Fragile and conflict affected situations in 2008 and the Rent(as % of GDP) in Heavily indebted poor countries in 2009?
Keep it short and to the point. -1.86. What is the difference between the Rent(as % of GDP) of Fragile and conflict affected situations in 2008 and the Rent(as % of GDP) of Azerbaijan in 2009?
Offer a very short reply. 0.59. What is the difference between the Rent(as % of GDP) in Fragile and conflict affected situations in 2008 and the Rent(as % of GDP) in Madagascar in 2009?
Provide a short and direct response. 0.6. What is the difference between the Rent(as % of GDP) in Heavily indebted poor countries in 2008 and the Rent(as % of GDP) in Azerbaijan in 2009?
Offer a terse response. 2.49. What is the difference between the Rent(as % of GDP) in Heavily indebted poor countries in 2008 and the Rent(as % of GDP) in Madagascar in 2009?
Keep it short and to the point. 2.5. What is the difference between the Rent(as % of GDP) in Azerbaijan in 2008 and the Rent(as % of GDP) in Madagascar in 2009?
Provide a short and direct response. -0. What is the difference between the Rent(as % of GDP) of Fragile and conflict affected situations in 2008 and the Rent(as % of GDP) of Heavily indebted poor countries in 2010?
Your response must be concise. -3.05. What is the difference between the Rent(as % of GDP) of Fragile and conflict affected situations in 2008 and the Rent(as % of GDP) of Azerbaijan in 2010?
Offer a terse response. 0.5. What is the difference between the Rent(as % of GDP) in Fragile and conflict affected situations in 2008 and the Rent(as % of GDP) in Madagascar in 2010?
Your answer should be very brief. 0.27. What is the difference between the Rent(as % of GDP) in Heavily indebted poor countries in 2008 and the Rent(as % of GDP) in Azerbaijan in 2010?
Your answer should be compact. 2.39. What is the difference between the Rent(as % of GDP) of Heavily indebted poor countries in 2008 and the Rent(as % of GDP) of Madagascar in 2010?
Your answer should be compact. 2.17. What is the difference between the Rent(as % of GDP) of Azerbaijan in 2008 and the Rent(as % of GDP) of Madagascar in 2010?
Provide a short and direct response. -0.33. What is the difference between the Rent(as % of GDP) of Fragile and conflict affected situations in 2008 and the Rent(as % of GDP) of Heavily indebted poor countries in 2011?
Provide a succinct answer. -4.05. What is the difference between the Rent(as % of GDP) of Fragile and conflict affected situations in 2008 and the Rent(as % of GDP) of Azerbaijan in 2011?
Your answer should be compact. 0.46. What is the difference between the Rent(as % of GDP) in Fragile and conflict affected situations in 2008 and the Rent(as % of GDP) in Madagascar in 2011?
Keep it short and to the point. -0.28. What is the difference between the Rent(as % of GDP) in Heavily indebted poor countries in 2008 and the Rent(as % of GDP) in Azerbaijan in 2011?
Ensure brevity in your answer.  2.36. What is the difference between the Rent(as % of GDP) of Heavily indebted poor countries in 2008 and the Rent(as % of GDP) of Madagascar in 2011?
Offer a terse response. 1.61. What is the difference between the Rent(as % of GDP) in Azerbaijan in 2008 and the Rent(as % of GDP) in Madagascar in 2011?
Your response must be concise. -0.89. What is the difference between the Rent(as % of GDP) in Fragile and conflict affected situations in 2008 and the Rent(as % of GDP) in Heavily indebted poor countries in 2012?
Give a very brief answer. -3.97. What is the difference between the Rent(as % of GDP) of Fragile and conflict affected situations in 2008 and the Rent(as % of GDP) of Azerbaijan in 2012?
Your response must be concise. 0.43. What is the difference between the Rent(as % of GDP) in Fragile and conflict affected situations in 2008 and the Rent(as % of GDP) in Madagascar in 2012?
Provide a succinct answer. -0.2. What is the difference between the Rent(as % of GDP) of Heavily indebted poor countries in 2008 and the Rent(as % of GDP) of Azerbaijan in 2012?
Your answer should be very brief. 2.33. What is the difference between the Rent(as % of GDP) in Heavily indebted poor countries in 2008 and the Rent(as % of GDP) in Madagascar in 2012?
Offer a terse response. 1.7. What is the difference between the Rent(as % of GDP) in Azerbaijan in 2008 and the Rent(as % of GDP) in Madagascar in 2012?
Your answer should be very brief. -0.8. What is the difference between the Rent(as % of GDP) of Fragile and conflict affected situations in 2009 and the Rent(as % of GDP) of Heavily indebted poor countries in 2010?
Offer a terse response. -2.95. What is the difference between the Rent(as % of GDP) of Fragile and conflict affected situations in 2009 and the Rent(as % of GDP) of Azerbaijan in 2010?
Your response must be concise. 0.59. What is the difference between the Rent(as % of GDP) in Fragile and conflict affected situations in 2009 and the Rent(as % of GDP) in Madagascar in 2010?
Give a very brief answer. 0.37. What is the difference between the Rent(as % of GDP) in Heavily indebted poor countries in 2009 and the Rent(as % of GDP) in Azerbaijan in 2010?
Provide a succinct answer. 2.36. What is the difference between the Rent(as % of GDP) in Heavily indebted poor countries in 2009 and the Rent(as % of GDP) in Madagascar in 2010?
Ensure brevity in your answer.  2.13. What is the difference between the Rent(as % of GDP) in Azerbaijan in 2009 and the Rent(as % of GDP) in Madagascar in 2010?
Provide a succinct answer. -0.32. What is the difference between the Rent(as % of GDP) of Fragile and conflict affected situations in 2009 and the Rent(as % of GDP) of Heavily indebted poor countries in 2011?
Offer a terse response. -3.96. What is the difference between the Rent(as % of GDP) of Fragile and conflict affected situations in 2009 and the Rent(as % of GDP) of Azerbaijan in 2011?
Provide a short and direct response. 0.56. What is the difference between the Rent(as % of GDP) of Fragile and conflict affected situations in 2009 and the Rent(as % of GDP) of Madagascar in 2011?
Your answer should be very brief. -0.19. What is the difference between the Rent(as % of GDP) in Heavily indebted poor countries in 2009 and the Rent(as % of GDP) in Azerbaijan in 2011?
Provide a succinct answer. 2.32. What is the difference between the Rent(as % of GDP) of Heavily indebted poor countries in 2009 and the Rent(as % of GDP) of Madagascar in 2011?
Keep it short and to the point. 1.58. What is the difference between the Rent(as % of GDP) in Azerbaijan in 2009 and the Rent(as % of GDP) in Madagascar in 2011?
Make the answer very short. -0.88. What is the difference between the Rent(as % of GDP) of Fragile and conflict affected situations in 2009 and the Rent(as % of GDP) of Heavily indebted poor countries in 2012?
Give a very brief answer. -3.87. What is the difference between the Rent(as % of GDP) in Fragile and conflict affected situations in 2009 and the Rent(as % of GDP) in Azerbaijan in 2012?
Your answer should be compact. 0.52. What is the difference between the Rent(as % of GDP) in Fragile and conflict affected situations in 2009 and the Rent(as % of GDP) in Madagascar in 2012?
Offer a terse response. -0.11. What is the difference between the Rent(as % of GDP) in Heavily indebted poor countries in 2009 and the Rent(as % of GDP) in Azerbaijan in 2012?
Make the answer very short. 2.29. What is the difference between the Rent(as % of GDP) of Heavily indebted poor countries in 2009 and the Rent(as % of GDP) of Madagascar in 2012?
Ensure brevity in your answer.  1.66. What is the difference between the Rent(as % of GDP) of Azerbaijan in 2009 and the Rent(as % of GDP) of Madagascar in 2012?
Offer a terse response. -0.79. What is the difference between the Rent(as % of GDP) of Fragile and conflict affected situations in 2010 and the Rent(as % of GDP) of Heavily indebted poor countries in 2011?
Provide a short and direct response. -3.59. What is the difference between the Rent(as % of GDP) in Fragile and conflict affected situations in 2010 and the Rent(as % of GDP) in Azerbaijan in 2011?
Your answer should be compact. 0.93. What is the difference between the Rent(as % of GDP) of Fragile and conflict affected situations in 2010 and the Rent(as % of GDP) of Madagascar in 2011?
Make the answer very short. 0.18. What is the difference between the Rent(as % of GDP) in Heavily indebted poor countries in 2010 and the Rent(as % of GDP) in Azerbaijan in 2011?
Provide a short and direct response. 3.51. What is the difference between the Rent(as % of GDP) in Heavily indebted poor countries in 2010 and the Rent(as % of GDP) in Madagascar in 2011?
Give a very brief answer. 2.76. What is the difference between the Rent(as % of GDP) in Azerbaijan in 2010 and the Rent(as % of GDP) in Madagascar in 2011?
Keep it short and to the point. -0.78. What is the difference between the Rent(as % of GDP) of Fragile and conflict affected situations in 2010 and the Rent(as % of GDP) of Heavily indebted poor countries in 2012?
Keep it short and to the point. -3.5. What is the difference between the Rent(as % of GDP) in Fragile and conflict affected situations in 2010 and the Rent(as % of GDP) in Azerbaijan in 2012?
Ensure brevity in your answer.  0.89. What is the difference between the Rent(as % of GDP) in Fragile and conflict affected situations in 2010 and the Rent(as % of GDP) in Madagascar in 2012?
Ensure brevity in your answer.  0.26. What is the difference between the Rent(as % of GDP) of Heavily indebted poor countries in 2010 and the Rent(as % of GDP) of Azerbaijan in 2012?
Your answer should be compact. 3.48. What is the difference between the Rent(as % of GDP) in Heavily indebted poor countries in 2010 and the Rent(as % of GDP) in Madagascar in 2012?
Provide a succinct answer. 2.85. What is the difference between the Rent(as % of GDP) in Azerbaijan in 2010 and the Rent(as % of GDP) in Madagascar in 2012?
Your answer should be compact. -0.7. What is the difference between the Rent(as % of GDP) in Fragile and conflict affected situations in 2011 and the Rent(as % of GDP) in Heavily indebted poor countries in 2012?
Make the answer very short. -3.04. What is the difference between the Rent(as % of GDP) in Fragile and conflict affected situations in 2011 and the Rent(as % of GDP) in Azerbaijan in 2012?
Provide a short and direct response. 1.36. What is the difference between the Rent(as % of GDP) in Fragile and conflict affected situations in 2011 and the Rent(as % of GDP) in Madagascar in 2012?
Your response must be concise. 0.73. What is the difference between the Rent(as % of GDP) in Heavily indebted poor countries in 2011 and the Rent(as % of GDP) in Azerbaijan in 2012?
Your answer should be compact. 4.48. What is the difference between the Rent(as % of GDP) of Heavily indebted poor countries in 2011 and the Rent(as % of GDP) of Madagascar in 2012?
Offer a very short reply. 3.85. What is the difference between the Rent(as % of GDP) in Azerbaijan in 2011 and the Rent(as % of GDP) in Madagascar in 2012?
Offer a very short reply. -0.67. What is the average Rent(as % of GDP) of Fragile and conflict affected situations per year?
Give a very brief answer. 0.83. What is the average Rent(as % of GDP) of Heavily indebted poor countries per year?
Give a very brief answer. 2.97. What is the average Rent(as % of GDP) of Azerbaijan per year?
Your response must be concise. 0.06. What is the average Rent(as % of GDP) in Madagascar per year?
Offer a terse response. 0.26. In the year 2005, what is the difference between the Rent(as % of GDP) of Fragile and conflict affected situations and Rent(as % of GDP) of Heavily indebted poor countries?
Your response must be concise. -0.89. In the year 2005, what is the difference between the Rent(as % of GDP) in Fragile and conflict affected situations and Rent(as % of GDP) in Azerbaijan?
Your response must be concise. 0.27. In the year 2005, what is the difference between the Rent(as % of GDP) in Fragile and conflict affected situations and Rent(as % of GDP) in Madagascar?
Your answer should be compact. 0.27. In the year 2005, what is the difference between the Rent(as % of GDP) of Heavily indebted poor countries and Rent(as % of GDP) of Azerbaijan?
Your answer should be very brief. 1.16. In the year 2005, what is the difference between the Rent(as % of GDP) in Heavily indebted poor countries and Rent(as % of GDP) in Madagascar?
Give a very brief answer. 1.16. In the year 2005, what is the difference between the Rent(as % of GDP) of Azerbaijan and Rent(as % of GDP) of Madagascar?
Provide a short and direct response. 0. In the year 2006, what is the difference between the Rent(as % of GDP) in Fragile and conflict affected situations and Rent(as % of GDP) in Heavily indebted poor countries?
Ensure brevity in your answer.  -1.73. In the year 2006, what is the difference between the Rent(as % of GDP) of Fragile and conflict affected situations and Rent(as % of GDP) of Azerbaijan?
Offer a terse response. 0.55. In the year 2006, what is the difference between the Rent(as % of GDP) of Fragile and conflict affected situations and Rent(as % of GDP) of Madagascar?
Keep it short and to the point. 0.55. In the year 2006, what is the difference between the Rent(as % of GDP) in Heavily indebted poor countries and Rent(as % of GDP) in Azerbaijan?
Offer a very short reply. 2.28. In the year 2006, what is the difference between the Rent(as % of GDP) in Heavily indebted poor countries and Rent(as % of GDP) in Madagascar?
Provide a succinct answer. 2.28. In the year 2006, what is the difference between the Rent(as % of GDP) in Azerbaijan and Rent(as % of GDP) in Madagascar?
Your answer should be compact. -0. In the year 2007, what is the difference between the Rent(as % of GDP) in Fragile and conflict affected situations and Rent(as % of GDP) in Heavily indebted poor countries?
Make the answer very short. -1.92. In the year 2007, what is the difference between the Rent(as % of GDP) of Fragile and conflict affected situations and Rent(as % of GDP) of Azerbaijan?
Make the answer very short. 0.54. In the year 2007, what is the difference between the Rent(as % of GDP) of Fragile and conflict affected situations and Rent(as % of GDP) of Madagascar?
Offer a terse response. 0.55. In the year 2007, what is the difference between the Rent(as % of GDP) of Heavily indebted poor countries and Rent(as % of GDP) of Azerbaijan?
Your response must be concise. 2.47. In the year 2007, what is the difference between the Rent(as % of GDP) in Heavily indebted poor countries and Rent(as % of GDP) in Madagascar?
Provide a succinct answer. 2.47. In the year 2007, what is the difference between the Rent(as % of GDP) of Azerbaijan and Rent(as % of GDP) of Madagascar?
Ensure brevity in your answer.  0. In the year 2008, what is the difference between the Rent(as % of GDP) in Fragile and conflict affected situations and Rent(as % of GDP) in Heavily indebted poor countries?
Offer a very short reply. -1.9. In the year 2008, what is the difference between the Rent(as % of GDP) in Fragile and conflict affected situations and Rent(as % of GDP) in Azerbaijan?
Make the answer very short. 0.6. In the year 2008, what is the difference between the Rent(as % of GDP) of Fragile and conflict affected situations and Rent(as % of GDP) of Madagascar?
Offer a very short reply. 0.6. In the year 2008, what is the difference between the Rent(as % of GDP) in Heavily indebted poor countries and Rent(as % of GDP) in Azerbaijan?
Offer a terse response. 2.5. In the year 2008, what is the difference between the Rent(as % of GDP) of Heavily indebted poor countries and Rent(as % of GDP) of Madagascar?
Provide a succinct answer. 2.5. In the year 2008, what is the difference between the Rent(as % of GDP) of Azerbaijan and Rent(as % of GDP) of Madagascar?
Provide a succinct answer. -0. In the year 2009, what is the difference between the Rent(as % of GDP) of Fragile and conflict affected situations and Rent(as % of GDP) of Heavily indebted poor countries?
Provide a short and direct response. -1.77. In the year 2009, what is the difference between the Rent(as % of GDP) of Fragile and conflict affected situations and Rent(as % of GDP) of Azerbaijan?
Give a very brief answer. 0.69. In the year 2009, what is the difference between the Rent(as % of GDP) of Fragile and conflict affected situations and Rent(as % of GDP) of Madagascar?
Your answer should be very brief. 0.7. In the year 2009, what is the difference between the Rent(as % of GDP) of Heavily indebted poor countries and Rent(as % of GDP) of Azerbaijan?
Provide a short and direct response. 2.45. In the year 2009, what is the difference between the Rent(as % of GDP) of Heavily indebted poor countries and Rent(as % of GDP) of Madagascar?
Ensure brevity in your answer.  2.46. In the year 2009, what is the difference between the Rent(as % of GDP) of Azerbaijan and Rent(as % of GDP) of Madagascar?
Make the answer very short. 0.01. In the year 2010, what is the difference between the Rent(as % of GDP) in Fragile and conflict affected situations and Rent(as % of GDP) in Heavily indebted poor countries?
Keep it short and to the point. -2.58. In the year 2010, what is the difference between the Rent(as % of GDP) in Fragile and conflict affected situations and Rent(as % of GDP) in Azerbaijan?
Offer a terse response. 0.96. In the year 2010, what is the difference between the Rent(as % of GDP) in Fragile and conflict affected situations and Rent(as % of GDP) in Madagascar?
Keep it short and to the point. 0.73. In the year 2010, what is the difference between the Rent(as % of GDP) in Heavily indebted poor countries and Rent(as % of GDP) in Azerbaijan?
Your response must be concise. 3.54. In the year 2010, what is the difference between the Rent(as % of GDP) of Heavily indebted poor countries and Rent(as % of GDP) of Madagascar?
Give a very brief answer. 3.32. In the year 2010, what is the difference between the Rent(as % of GDP) in Azerbaijan and Rent(as % of GDP) in Madagascar?
Offer a terse response. -0.22. In the year 2011, what is the difference between the Rent(as % of GDP) in Fragile and conflict affected situations and Rent(as % of GDP) in Heavily indebted poor countries?
Provide a short and direct response. -3.12. In the year 2011, what is the difference between the Rent(as % of GDP) in Fragile and conflict affected situations and Rent(as % of GDP) in Azerbaijan?
Offer a very short reply. 1.39. In the year 2011, what is the difference between the Rent(as % of GDP) of Fragile and conflict affected situations and Rent(as % of GDP) of Madagascar?
Offer a very short reply. 0.65. In the year 2011, what is the difference between the Rent(as % of GDP) of Heavily indebted poor countries and Rent(as % of GDP) of Azerbaijan?
Offer a very short reply. 4.52. In the year 2011, what is the difference between the Rent(as % of GDP) of Heavily indebted poor countries and Rent(as % of GDP) of Madagascar?
Ensure brevity in your answer.  3.77. In the year 2011, what is the difference between the Rent(as % of GDP) in Azerbaijan and Rent(as % of GDP) in Madagascar?
Provide a short and direct response. -0.75. In the year 2012, what is the difference between the Rent(as % of GDP) in Fragile and conflict affected situations and Rent(as % of GDP) in Heavily indebted poor countries?
Give a very brief answer. -3.26. In the year 2012, what is the difference between the Rent(as % of GDP) in Fragile and conflict affected situations and Rent(as % of GDP) in Azerbaijan?
Give a very brief answer. 1.14. In the year 2012, what is the difference between the Rent(as % of GDP) of Fragile and conflict affected situations and Rent(as % of GDP) of Madagascar?
Make the answer very short. 0.51. In the year 2012, what is the difference between the Rent(as % of GDP) in Heavily indebted poor countries and Rent(as % of GDP) in Azerbaijan?
Your answer should be compact. 4.4. In the year 2012, what is the difference between the Rent(as % of GDP) in Heavily indebted poor countries and Rent(as % of GDP) in Madagascar?
Your response must be concise. 3.77. In the year 2012, what is the difference between the Rent(as % of GDP) of Azerbaijan and Rent(as % of GDP) of Madagascar?
Offer a very short reply. -0.63. What is the ratio of the Rent(as % of GDP) of Fragile and conflict affected situations in 2005 to that in 2006?
Offer a terse response. 0.49. What is the ratio of the Rent(as % of GDP) in Heavily indebted poor countries in 2005 to that in 2006?
Your answer should be compact. 0.51. What is the ratio of the Rent(as % of GDP) of Azerbaijan in 2005 to that in 2006?
Offer a terse response. 0.93. What is the ratio of the Rent(as % of GDP) of Madagascar in 2005 to that in 2006?
Your answer should be very brief. 0.15. What is the ratio of the Rent(as % of GDP) in Fragile and conflict affected situations in 2005 to that in 2007?
Keep it short and to the point. 0.49. What is the ratio of the Rent(as % of GDP) of Heavily indebted poor countries in 2005 to that in 2007?
Offer a terse response. 0.47. What is the ratio of the Rent(as % of GDP) in Azerbaijan in 2005 to that in 2007?
Offer a very short reply. 0.4. What is the ratio of the Rent(as % of GDP) of Madagascar in 2005 to that in 2007?
Your answer should be compact. 4.84. What is the ratio of the Rent(as % of GDP) of Fragile and conflict affected situations in 2005 to that in 2008?
Keep it short and to the point. 0.44. What is the ratio of the Rent(as % of GDP) of Heavily indebted poor countries in 2005 to that in 2008?
Your response must be concise. 0.46. What is the ratio of the Rent(as % of GDP) in Azerbaijan in 2005 to that in 2008?
Offer a very short reply. 0.28. What is the ratio of the Rent(as % of GDP) of Madagascar in 2005 to that in 2008?
Give a very brief answer. 0.09. What is the ratio of the Rent(as % of GDP) in Fragile and conflict affected situations in 2005 to that in 2009?
Your response must be concise. 0.38. What is the ratio of the Rent(as % of GDP) of Heavily indebted poor countries in 2005 to that in 2009?
Your answer should be compact. 0.47. What is the ratio of the Rent(as % of GDP) of Azerbaijan in 2005 to that in 2009?
Ensure brevity in your answer.  0.12. What is the ratio of the Rent(as % of GDP) in Madagascar in 2005 to that in 2009?
Offer a terse response. 0.1. What is the ratio of the Rent(as % of GDP) in Fragile and conflict affected situations in 2005 to that in 2010?
Your response must be concise. 0.25. What is the ratio of the Rent(as % of GDP) in Heavily indebted poor countries in 2005 to that in 2010?
Offer a terse response. 0.32. What is the ratio of the Rent(as % of GDP) in Azerbaijan in 2005 to that in 2010?
Make the answer very short. 0.02. What is the ratio of the Rent(as % of GDP) in Madagascar in 2005 to that in 2010?
Make the answer very short. 0. What is the ratio of the Rent(as % of GDP) of Fragile and conflict affected situations in 2005 to that in 2011?
Make the answer very short. 0.17. What is the ratio of the Rent(as % of GDP) of Heavily indebted poor countries in 2005 to that in 2011?
Give a very brief answer. 0.25. What is the ratio of the Rent(as % of GDP) in Azerbaijan in 2005 to that in 2011?
Make the answer very short. 0.01. What is the ratio of the Rent(as % of GDP) of Madagascar in 2005 to that in 2011?
Your answer should be compact. 0. What is the ratio of the Rent(as % of GDP) in Fragile and conflict affected situations in 2005 to that in 2012?
Keep it short and to the point. 0.2. What is the ratio of the Rent(as % of GDP) in Heavily indebted poor countries in 2005 to that in 2012?
Make the answer very short. 0.25. What is the ratio of the Rent(as % of GDP) in Azerbaijan in 2005 to that in 2012?
Your response must be concise. 0.01. What is the ratio of the Rent(as % of GDP) in Madagascar in 2005 to that in 2012?
Provide a short and direct response. 0. What is the ratio of the Rent(as % of GDP) of Heavily indebted poor countries in 2006 to that in 2007?
Your response must be concise. 0.93. What is the ratio of the Rent(as % of GDP) in Azerbaijan in 2006 to that in 2007?
Provide a succinct answer. 0.43. What is the ratio of the Rent(as % of GDP) of Madagascar in 2006 to that in 2007?
Your answer should be very brief. 31.38. What is the ratio of the Rent(as % of GDP) in Fragile and conflict affected situations in 2006 to that in 2008?
Your response must be concise. 0.91. What is the ratio of the Rent(as % of GDP) in Heavily indebted poor countries in 2006 to that in 2008?
Make the answer very short. 0.91. What is the ratio of the Rent(as % of GDP) in Azerbaijan in 2006 to that in 2008?
Give a very brief answer. 0.3. What is the ratio of the Rent(as % of GDP) of Madagascar in 2006 to that in 2008?
Your answer should be very brief. 0.56. What is the ratio of the Rent(as % of GDP) of Fragile and conflict affected situations in 2006 to that in 2009?
Your answer should be very brief. 0.78. What is the ratio of the Rent(as % of GDP) in Heavily indebted poor countries in 2006 to that in 2009?
Offer a very short reply. 0.93. What is the ratio of the Rent(as % of GDP) in Azerbaijan in 2006 to that in 2009?
Your answer should be compact. 0.13. What is the ratio of the Rent(as % of GDP) in Madagascar in 2006 to that in 2009?
Make the answer very short. 0.65. What is the ratio of the Rent(as % of GDP) in Fragile and conflict affected situations in 2006 to that in 2010?
Your answer should be very brief. 0.51. What is the ratio of the Rent(as % of GDP) in Heavily indebted poor countries in 2006 to that in 2010?
Offer a terse response. 0.63. What is the ratio of the Rent(as % of GDP) in Azerbaijan in 2006 to that in 2010?
Keep it short and to the point. 0.02. What is the ratio of the Rent(as % of GDP) of Madagascar in 2006 to that in 2010?
Keep it short and to the point. 0.01. What is the ratio of the Rent(as % of GDP) of Fragile and conflict affected situations in 2006 to that in 2011?
Your answer should be very brief. 0.36. What is the ratio of the Rent(as % of GDP) of Heavily indebted poor countries in 2006 to that in 2011?
Provide a succinct answer. 0.49. What is the ratio of the Rent(as % of GDP) of Azerbaijan in 2006 to that in 2011?
Your answer should be very brief. 0.01. What is the ratio of the Rent(as % of GDP) of Madagascar in 2006 to that in 2011?
Your answer should be compact. 0.01. What is the ratio of the Rent(as % of GDP) in Fragile and conflict affected situations in 2006 to that in 2012?
Your response must be concise. 0.42. What is the ratio of the Rent(as % of GDP) in Heavily indebted poor countries in 2006 to that in 2012?
Your response must be concise. 0.5. What is the ratio of the Rent(as % of GDP) in Azerbaijan in 2006 to that in 2012?
Make the answer very short. 0.01. What is the ratio of the Rent(as % of GDP) of Madagascar in 2006 to that in 2012?
Offer a terse response. 0.01. What is the ratio of the Rent(as % of GDP) of Fragile and conflict affected situations in 2007 to that in 2008?
Your answer should be very brief. 0.9. What is the ratio of the Rent(as % of GDP) in Heavily indebted poor countries in 2007 to that in 2008?
Make the answer very short. 0.99. What is the ratio of the Rent(as % of GDP) of Azerbaijan in 2007 to that in 2008?
Give a very brief answer. 0.69. What is the ratio of the Rent(as % of GDP) in Madagascar in 2007 to that in 2008?
Provide a succinct answer. 0.02. What is the ratio of the Rent(as % of GDP) of Fragile and conflict affected situations in 2007 to that in 2009?
Provide a succinct answer. 0.78. What is the ratio of the Rent(as % of GDP) of Heavily indebted poor countries in 2007 to that in 2009?
Offer a very short reply. 1. What is the ratio of the Rent(as % of GDP) in Azerbaijan in 2007 to that in 2009?
Offer a terse response. 0.29. What is the ratio of the Rent(as % of GDP) in Madagascar in 2007 to that in 2009?
Provide a succinct answer. 0.02. What is the ratio of the Rent(as % of GDP) of Fragile and conflict affected situations in 2007 to that in 2010?
Keep it short and to the point. 0.51. What is the ratio of the Rent(as % of GDP) in Heavily indebted poor countries in 2007 to that in 2010?
Your answer should be very brief. 0.68. What is the ratio of the Rent(as % of GDP) in Azerbaijan in 2007 to that in 2010?
Offer a terse response. 0.04. What is the ratio of the Rent(as % of GDP) in Madagascar in 2007 to that in 2010?
Make the answer very short. 0. What is the ratio of the Rent(as % of GDP) in Fragile and conflict affected situations in 2007 to that in 2011?
Offer a terse response. 0.36. What is the ratio of the Rent(as % of GDP) in Heavily indebted poor countries in 2007 to that in 2011?
Your answer should be very brief. 0.53. What is the ratio of the Rent(as % of GDP) in Azerbaijan in 2007 to that in 2011?
Ensure brevity in your answer.  0.03. What is the ratio of the Rent(as % of GDP) in Madagascar in 2007 to that in 2011?
Ensure brevity in your answer.  0. What is the ratio of the Rent(as % of GDP) of Fragile and conflict affected situations in 2007 to that in 2012?
Offer a very short reply. 0.42. What is the ratio of the Rent(as % of GDP) of Heavily indebted poor countries in 2007 to that in 2012?
Your answer should be very brief. 0.54. What is the ratio of the Rent(as % of GDP) in Azerbaijan in 2007 to that in 2012?
Make the answer very short. 0.03. What is the ratio of the Rent(as % of GDP) of Madagascar in 2007 to that in 2012?
Make the answer very short. 0. What is the ratio of the Rent(as % of GDP) of Fragile and conflict affected situations in 2008 to that in 2009?
Provide a succinct answer. 0.87. What is the ratio of the Rent(as % of GDP) in Heavily indebted poor countries in 2008 to that in 2009?
Provide a succinct answer. 1.02. What is the ratio of the Rent(as % of GDP) of Azerbaijan in 2008 to that in 2009?
Make the answer very short. 0.42. What is the ratio of the Rent(as % of GDP) of Madagascar in 2008 to that in 2009?
Give a very brief answer. 1.16. What is the ratio of the Rent(as % of GDP) in Fragile and conflict affected situations in 2008 to that in 2010?
Your answer should be compact. 0.57. What is the ratio of the Rent(as % of GDP) in Heavily indebted poor countries in 2008 to that in 2010?
Offer a very short reply. 0.69. What is the ratio of the Rent(as % of GDP) of Azerbaijan in 2008 to that in 2010?
Make the answer very short. 0.06. What is the ratio of the Rent(as % of GDP) in Madagascar in 2008 to that in 2010?
Offer a very short reply. 0.02. What is the ratio of the Rent(as % of GDP) of Fragile and conflict affected situations in 2008 to that in 2011?
Provide a succinct answer. 0.4. What is the ratio of the Rent(as % of GDP) in Heavily indebted poor countries in 2008 to that in 2011?
Provide a succinct answer. 0.54. What is the ratio of the Rent(as % of GDP) of Azerbaijan in 2008 to that in 2011?
Ensure brevity in your answer.  0.05. What is the ratio of the Rent(as % of GDP) of Madagascar in 2008 to that in 2011?
Your answer should be compact. 0.01. What is the ratio of the Rent(as % of GDP) of Fragile and conflict affected situations in 2008 to that in 2012?
Make the answer very short. 0.46. What is the ratio of the Rent(as % of GDP) of Heavily indebted poor countries in 2008 to that in 2012?
Make the answer very short. 0.55. What is the ratio of the Rent(as % of GDP) in Azerbaijan in 2008 to that in 2012?
Offer a very short reply. 0.04. What is the ratio of the Rent(as % of GDP) in Madagascar in 2008 to that in 2012?
Your response must be concise. 0.01. What is the ratio of the Rent(as % of GDP) of Fragile and conflict affected situations in 2009 to that in 2010?
Give a very brief answer. 0.66. What is the ratio of the Rent(as % of GDP) of Heavily indebted poor countries in 2009 to that in 2010?
Offer a terse response. 0.68. What is the ratio of the Rent(as % of GDP) of Azerbaijan in 2009 to that in 2010?
Your answer should be compact. 0.14. What is the ratio of the Rent(as % of GDP) in Madagascar in 2009 to that in 2010?
Keep it short and to the point. 0.02. What is the ratio of the Rent(as % of GDP) in Fragile and conflict affected situations in 2009 to that in 2011?
Give a very brief answer. 0.46. What is the ratio of the Rent(as % of GDP) in Heavily indebted poor countries in 2009 to that in 2011?
Your answer should be compact. 0.53. What is the ratio of the Rent(as % of GDP) of Azerbaijan in 2009 to that in 2011?
Give a very brief answer. 0.11. What is the ratio of the Rent(as % of GDP) of Madagascar in 2009 to that in 2011?
Keep it short and to the point. 0.01. What is the ratio of the Rent(as % of GDP) of Fragile and conflict affected situations in 2009 to that in 2012?
Offer a very short reply. 0.53. What is the ratio of the Rent(as % of GDP) in Heavily indebted poor countries in 2009 to that in 2012?
Your response must be concise. 0.54. What is the ratio of the Rent(as % of GDP) of Azerbaijan in 2009 to that in 2012?
Give a very brief answer. 0.09. What is the ratio of the Rent(as % of GDP) of Madagascar in 2009 to that in 2012?
Your answer should be very brief. 0.01. What is the ratio of the Rent(as % of GDP) of Fragile and conflict affected situations in 2010 to that in 2011?
Your answer should be very brief. 0.7. What is the ratio of the Rent(as % of GDP) of Heavily indebted poor countries in 2010 to that in 2011?
Keep it short and to the point. 0.78. What is the ratio of the Rent(as % of GDP) of Azerbaijan in 2010 to that in 2011?
Keep it short and to the point. 0.78. What is the ratio of the Rent(as % of GDP) of Madagascar in 2010 to that in 2011?
Provide a short and direct response. 0.38. What is the ratio of the Rent(as % of GDP) of Fragile and conflict affected situations in 2010 to that in 2012?
Your answer should be very brief. 0.81. What is the ratio of the Rent(as % of GDP) in Heavily indebted poor countries in 2010 to that in 2012?
Keep it short and to the point. 0.8. What is the ratio of the Rent(as % of GDP) of Azerbaijan in 2010 to that in 2012?
Offer a terse response. 0.63. What is the ratio of the Rent(as % of GDP) in Madagascar in 2010 to that in 2012?
Your response must be concise. 0.42. What is the ratio of the Rent(as % of GDP) in Fragile and conflict affected situations in 2011 to that in 2012?
Provide a succinct answer. 1.17. What is the ratio of the Rent(as % of GDP) in Heavily indebted poor countries in 2011 to that in 2012?
Provide a short and direct response. 1.02. What is the ratio of the Rent(as % of GDP) of Azerbaijan in 2011 to that in 2012?
Give a very brief answer. 0.81. What is the ratio of the Rent(as % of GDP) in Madagascar in 2011 to that in 2012?
Your response must be concise. 1.1. What is the difference between the highest and the second highest Rent(as % of GDP) in Fragile and conflict affected situations?
Your answer should be compact. 0.22. What is the difference between the highest and the second highest Rent(as % of GDP) of Heavily indebted poor countries?
Offer a very short reply. 0.09. What is the difference between the highest and the second highest Rent(as % of GDP) of Azerbaijan?
Make the answer very short. 0.03. What is the difference between the highest and the second highest Rent(as % of GDP) of Madagascar?
Keep it short and to the point. 0.08. What is the difference between the highest and the lowest Rent(as % of GDP) in Fragile and conflict affected situations?
Keep it short and to the point. 1.27. What is the difference between the highest and the lowest Rent(as % of GDP) of Heavily indebted poor countries?
Your response must be concise. 3.5. What is the difference between the highest and the lowest Rent(as % of GDP) in Azerbaijan?
Provide a short and direct response. 0.18. What is the difference between the highest and the lowest Rent(as % of GDP) in Madagascar?
Keep it short and to the point. 0.89. 